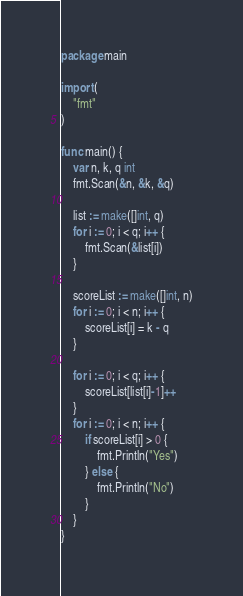<code> <loc_0><loc_0><loc_500><loc_500><_Go_>package main

import (
	"fmt"
)

func main() {
	var n, k, q int
	fmt.Scan(&n, &k, &q)

	list := make([]int, q)
	for i := 0; i < q; i++ {
		fmt.Scan(&list[i])
	}

	scoreList := make([]int, n)
	for i := 0; i < n; i++ {
		scoreList[i] = k - q
	}

	for i := 0; i < q; i++ {
		scoreList[list[i]-1]++
	}
	for i := 0; i < n; i++ {
		if scoreList[i] > 0 {
			fmt.Println("Yes")
		} else {
			fmt.Println("No")
		}
	}
}
</code> 